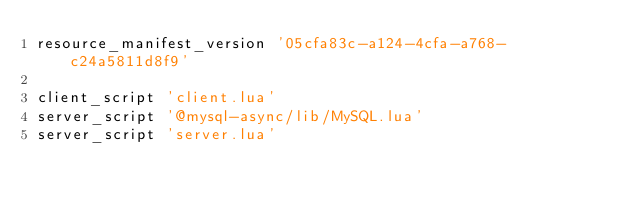<code> <loc_0><loc_0><loc_500><loc_500><_Lua_>resource_manifest_version '05cfa83c-a124-4cfa-a768-c24a5811d8f9'

client_script 'client.lua'
server_script '@mysql-async/lib/MySQL.lua'
server_script 'server.lua'</code> 